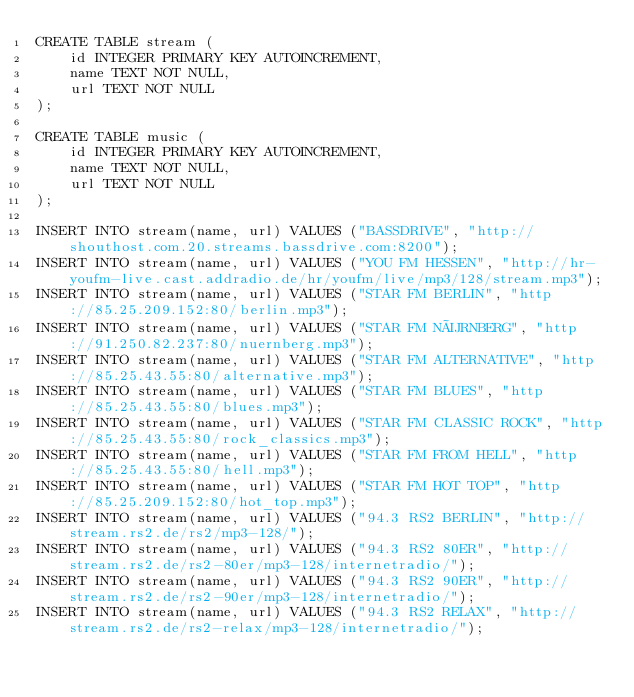<code> <loc_0><loc_0><loc_500><loc_500><_SQL_>CREATE TABLE stream (
    id INTEGER PRIMARY KEY AUTOINCREMENT,
    name TEXT NOT NULL,
    url TEXT NOT NULL
);

CREATE TABLE music (
    id INTEGER PRIMARY KEY AUTOINCREMENT,
    name TEXT NOT NULL,
    url TEXT NOT NULL
);

INSERT INTO stream(name, url) VALUES ("BASSDRIVE", "http://shouthost.com.20.streams.bassdrive.com:8200");
INSERT INTO stream(name, url) VALUES ("YOU FM HESSEN", "http://hr-youfm-live.cast.addradio.de/hr/youfm/live/mp3/128/stream.mp3");
INSERT INTO stream(name, url) VALUES ("STAR FM BERLIN", "http://85.25.209.152:80/berlin.mp3");
INSERT INTO stream(name, url) VALUES ("STAR FM NÜRNBERG", "http://91.250.82.237:80/nuernberg.mp3");
INSERT INTO stream(name, url) VALUES ("STAR FM ALTERNATIVE", "http://85.25.43.55:80/alternative.mp3");
INSERT INTO stream(name, url) VALUES ("STAR FM BLUES", "http://85.25.43.55:80/blues.mp3");
INSERT INTO stream(name, url) VALUES ("STAR FM CLASSIC ROCK", "http://85.25.43.55:80/rock_classics.mp3");
INSERT INTO stream(name, url) VALUES ("STAR FM FROM HELL", "http://85.25.43.55:80/hell.mp3");
INSERT INTO stream(name, url) VALUES ("STAR FM HOT TOP", "http://85.25.209.152:80/hot_top.mp3");
INSERT INTO stream(name, url) VALUES ("94.3 RS2 BERLIN", "http://stream.rs2.de/rs2/mp3-128/");
INSERT INTO stream(name, url) VALUES ("94.3 RS2 80ER", "http://stream.rs2.de/rs2-80er/mp3-128/internetradio/");
INSERT INTO stream(name, url) VALUES ("94.3 RS2 90ER", "http://stream.rs2.de/rs2-90er/mp3-128/internetradio/");
INSERT INTO stream(name, url) VALUES ("94.3 RS2 RELAX", "http://stream.rs2.de/rs2-relax/mp3-128/internetradio/");</code> 